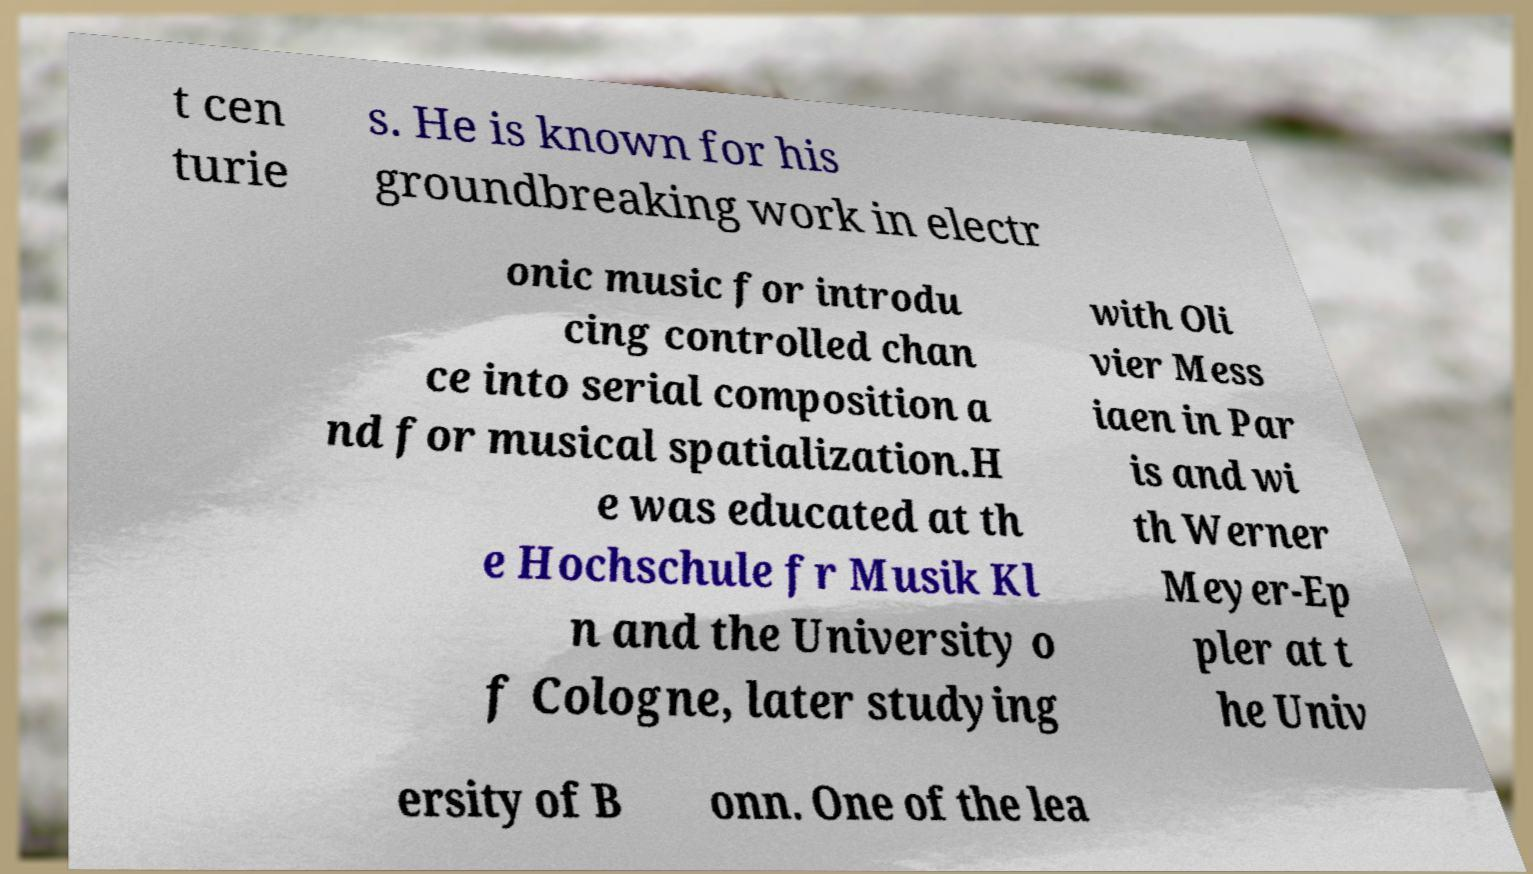What messages or text are displayed in this image? I need them in a readable, typed format. t cen turie s. He is known for his groundbreaking work in electr onic music for introdu cing controlled chan ce into serial composition a nd for musical spatialization.H e was educated at th e Hochschule fr Musik Kl n and the University o f Cologne, later studying with Oli vier Mess iaen in Par is and wi th Werner Meyer-Ep pler at t he Univ ersity of B onn. One of the lea 